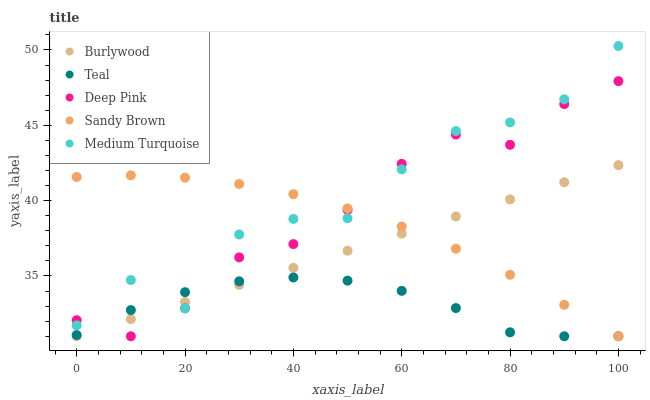Does Teal have the minimum area under the curve?
Answer yes or no. Yes. Does Medium Turquoise have the maximum area under the curve?
Answer yes or no. Yes. Does Deep Pink have the minimum area under the curve?
Answer yes or no. No. Does Deep Pink have the maximum area under the curve?
Answer yes or no. No. Is Burlywood the smoothest?
Answer yes or no. Yes. Is Medium Turquoise the roughest?
Answer yes or no. Yes. Is Deep Pink the smoothest?
Answer yes or no. No. Is Deep Pink the roughest?
Answer yes or no. No. Does Burlywood have the lowest value?
Answer yes or no. Yes. Does Medium Turquoise have the lowest value?
Answer yes or no. No. Does Medium Turquoise have the highest value?
Answer yes or no. Yes. Does Deep Pink have the highest value?
Answer yes or no. No. Does Burlywood intersect Sandy Brown?
Answer yes or no. Yes. Is Burlywood less than Sandy Brown?
Answer yes or no. No. Is Burlywood greater than Sandy Brown?
Answer yes or no. No. 